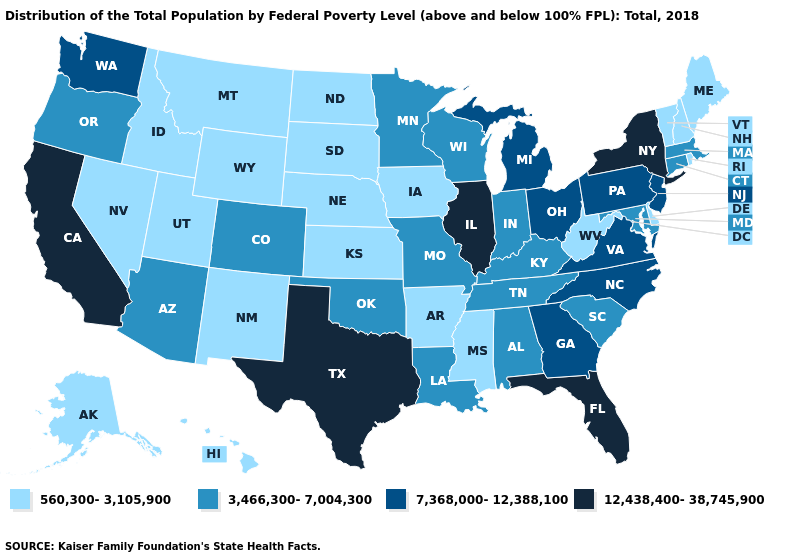What is the value of North Dakota?
Short answer required. 560,300-3,105,900. Among the states that border Arkansas , does Mississippi have the lowest value?
Short answer required. Yes. Does Iowa have the same value as North Dakota?
Be succinct. Yes. Name the states that have a value in the range 12,438,400-38,745,900?
Be succinct. California, Florida, Illinois, New York, Texas. Which states hav the highest value in the MidWest?
Quick response, please. Illinois. What is the value of Oregon?
Write a very short answer. 3,466,300-7,004,300. What is the value of Hawaii?
Answer briefly. 560,300-3,105,900. Does the map have missing data?
Short answer required. No. Does Nebraska have a lower value than Minnesota?
Quick response, please. Yes. What is the value of Rhode Island?
Be succinct. 560,300-3,105,900. What is the lowest value in the USA?
Keep it brief. 560,300-3,105,900. What is the highest value in the USA?
Give a very brief answer. 12,438,400-38,745,900. What is the lowest value in the USA?
Write a very short answer. 560,300-3,105,900. Does New Hampshire have the lowest value in the Northeast?
Be succinct. Yes. How many symbols are there in the legend?
Answer briefly. 4. 